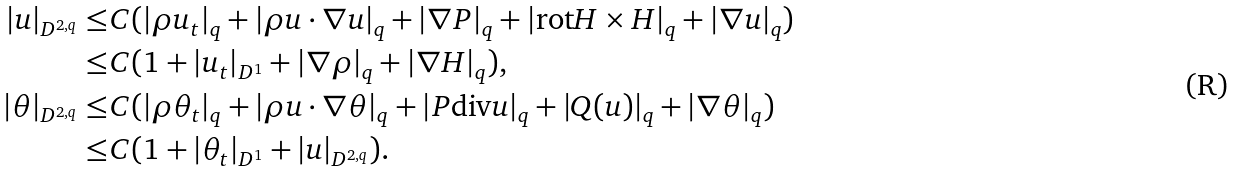Convert formula to latex. <formula><loc_0><loc_0><loc_500><loc_500>| u | _ { D ^ { 2 , q } } \leq & C ( | \rho u _ { t } | _ { q } + | \rho u \cdot \nabla u | _ { q } + | \nabla P | _ { q } + | \text {rot} H \times H | _ { q } + | \nabla u | _ { q } ) \\ \leq & C ( 1 + | u _ { t } | _ { D ^ { 1 } } + | \nabla \rho | _ { q } + | \nabla H | _ { q } ) , \\ | \theta | _ { D ^ { 2 , q } } \leq & C ( | \rho \theta _ { t } | _ { q } + | \rho u \cdot \nabla \theta | _ { q } + | P \text {div} u | _ { q } + | Q ( u ) | _ { q } + | \nabla \theta | _ { q } ) \\ \leq & C ( 1 + | \theta _ { t } | _ { D ^ { 1 } } + | u | _ { D ^ { 2 , q } } ) .</formula> 